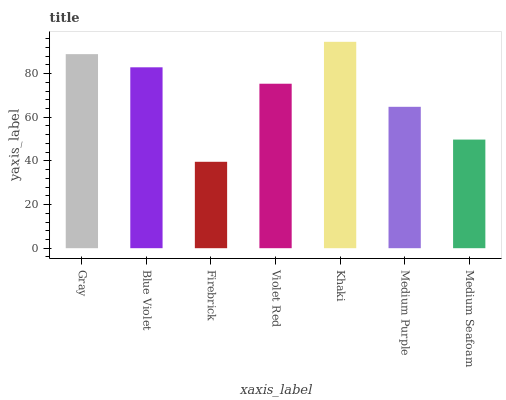Is Khaki the maximum?
Answer yes or no. Yes. Is Blue Violet the minimum?
Answer yes or no. No. Is Blue Violet the maximum?
Answer yes or no. No. Is Gray greater than Blue Violet?
Answer yes or no. Yes. Is Blue Violet less than Gray?
Answer yes or no. Yes. Is Blue Violet greater than Gray?
Answer yes or no. No. Is Gray less than Blue Violet?
Answer yes or no. No. Is Violet Red the high median?
Answer yes or no. Yes. Is Violet Red the low median?
Answer yes or no. Yes. Is Medium Seafoam the high median?
Answer yes or no. No. Is Firebrick the low median?
Answer yes or no. No. 